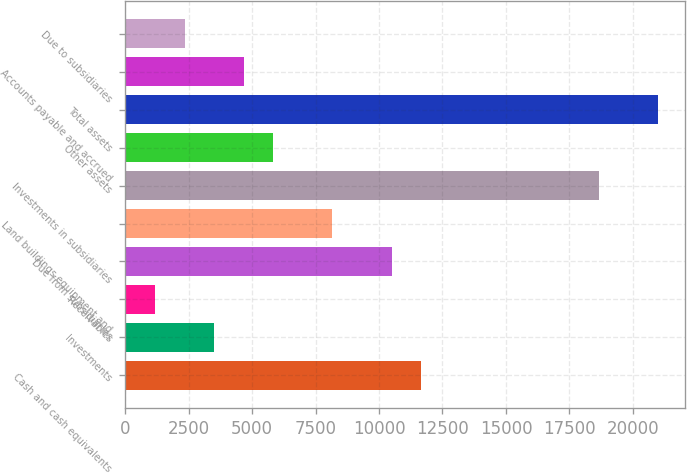Convert chart. <chart><loc_0><loc_0><loc_500><loc_500><bar_chart><fcel>Cash and cash equivalents<fcel>Investments<fcel>Receivables<fcel>Due from subsidiaries<fcel>Land buildings equipment and<fcel>Investments in subsidiaries<fcel>Other assets<fcel>Total assets<fcel>Accounts payable and accrued<fcel>Due to subsidiaries<nl><fcel>11661<fcel>3500.4<fcel>1168.8<fcel>10495.2<fcel>8163.6<fcel>18655.8<fcel>5832<fcel>20987.4<fcel>4666.2<fcel>2334.6<nl></chart> 